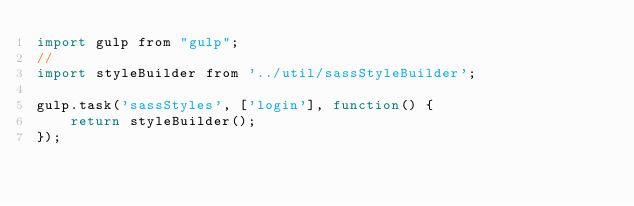<code> <loc_0><loc_0><loc_500><loc_500><_JavaScript_>import gulp from "gulp";
//
import styleBuilder from '../util/sassStyleBuilder';

gulp.task('sassStyles', ['login'], function() {
    return styleBuilder();
});</code> 